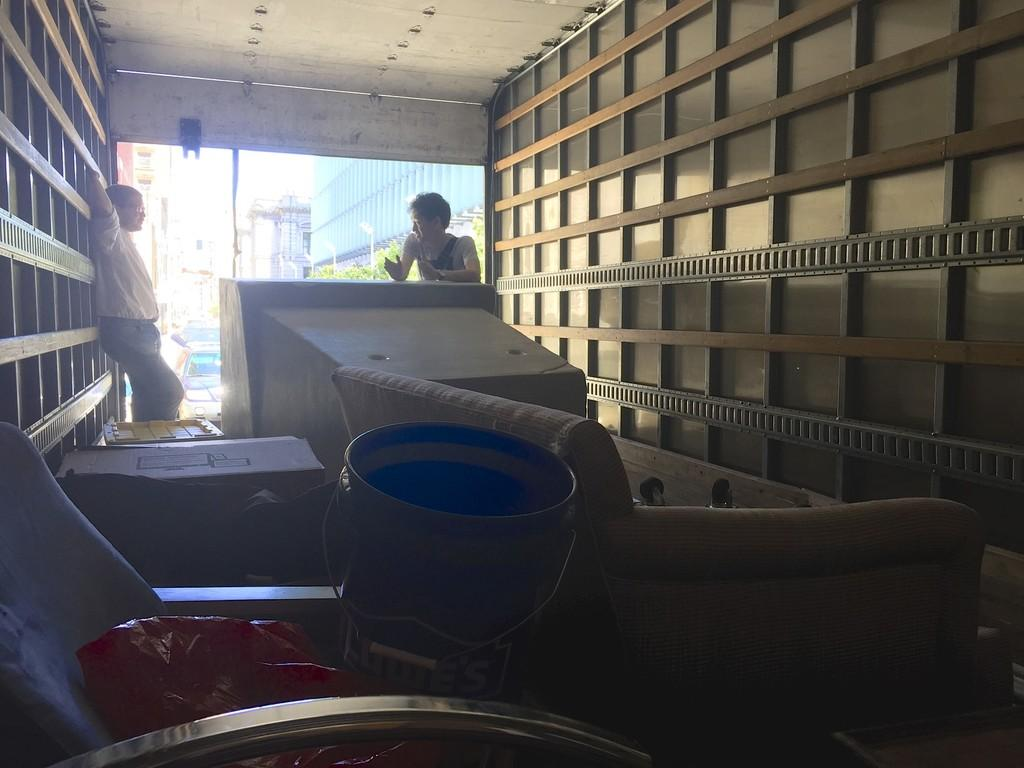What type of furniture can be seen in the image? There are chairs in the image. What object is used for holding or carrying items? There is a bucket in the image. What device is present for displaying information? A monitor is present in the image. How many people are in the image? There are 2 people in the image. What type of vegetation is visible in the image? There are plants visible in the image. What type of structures can be seen in the image? There are buildings in the image. What type of transportation is visible in the image? There are vehicles in the image. What type of insurance is required for the vehicles in the image? There is no information about insurance in the image, as it focuses on the presence of vehicles and other objects. What color is the ink used to write on the monitor in the image? There is no writing or ink present on the monitor in the image. 